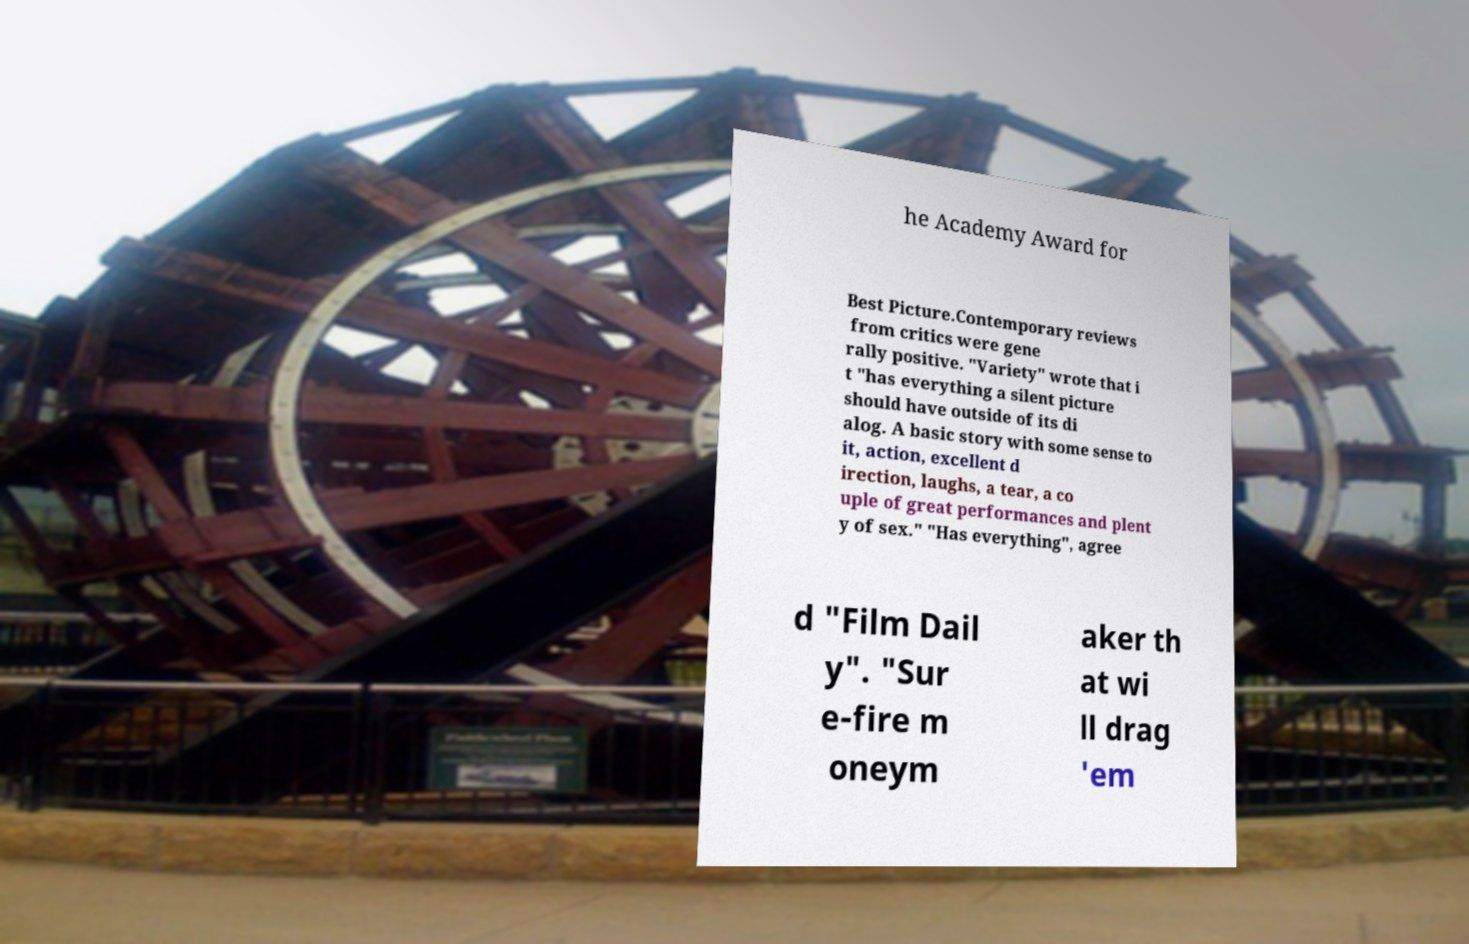Could you assist in decoding the text presented in this image and type it out clearly? he Academy Award for Best Picture.Contemporary reviews from critics were gene rally positive. "Variety" wrote that i t "has everything a silent picture should have outside of its di alog. A basic story with some sense to it, action, excellent d irection, laughs, a tear, a co uple of great performances and plent y of sex." "Has everything", agree d "Film Dail y". "Sur e-fire m oneym aker th at wi ll drag 'em 